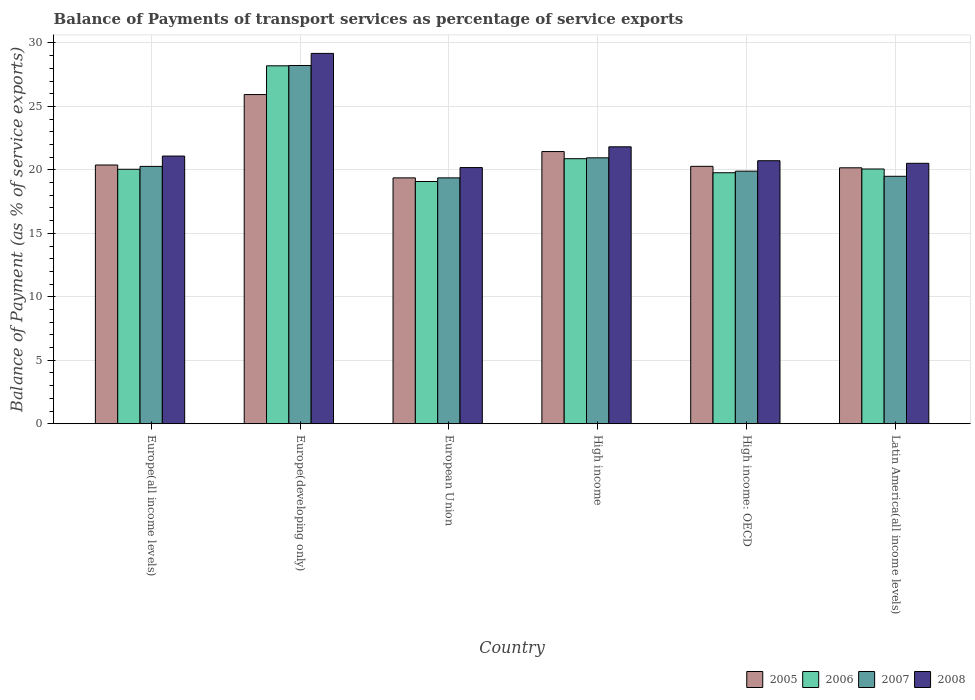How many bars are there on the 6th tick from the left?
Offer a very short reply. 4. What is the label of the 4th group of bars from the left?
Your response must be concise. High income. What is the balance of payments of transport services in 2006 in European Union?
Offer a very short reply. 19.09. Across all countries, what is the maximum balance of payments of transport services in 2006?
Offer a terse response. 28.2. Across all countries, what is the minimum balance of payments of transport services in 2005?
Your answer should be compact. 19.37. In which country was the balance of payments of transport services in 2005 maximum?
Offer a terse response. Europe(developing only). What is the total balance of payments of transport services in 2006 in the graph?
Offer a terse response. 128.07. What is the difference between the balance of payments of transport services in 2005 in Europe(all income levels) and that in Latin America(all income levels)?
Provide a succinct answer. 0.22. What is the difference between the balance of payments of transport services in 2005 in Latin America(all income levels) and the balance of payments of transport services in 2007 in Europe(all income levels)?
Provide a succinct answer. -0.11. What is the average balance of payments of transport services in 2008 per country?
Provide a succinct answer. 22.25. What is the difference between the balance of payments of transport services of/in 2007 and balance of payments of transport services of/in 2005 in High income?
Offer a terse response. -0.49. What is the ratio of the balance of payments of transport services in 2005 in Europe(all income levels) to that in High income?
Ensure brevity in your answer.  0.95. What is the difference between the highest and the second highest balance of payments of transport services in 2005?
Offer a very short reply. 5.55. What is the difference between the highest and the lowest balance of payments of transport services in 2006?
Your answer should be compact. 9.11. In how many countries, is the balance of payments of transport services in 2006 greater than the average balance of payments of transport services in 2006 taken over all countries?
Offer a very short reply. 1. Is the sum of the balance of payments of transport services in 2005 in Europe(developing only) and High income: OECD greater than the maximum balance of payments of transport services in 2007 across all countries?
Provide a succinct answer. Yes. Is it the case that in every country, the sum of the balance of payments of transport services in 2005 and balance of payments of transport services in 2007 is greater than the sum of balance of payments of transport services in 2008 and balance of payments of transport services in 2006?
Ensure brevity in your answer.  No. How many bars are there?
Your answer should be compact. 24. Are all the bars in the graph horizontal?
Offer a terse response. No. How many countries are there in the graph?
Your answer should be compact. 6. What is the difference between two consecutive major ticks on the Y-axis?
Keep it short and to the point. 5. Does the graph contain any zero values?
Offer a very short reply. No. Does the graph contain grids?
Your response must be concise. Yes. Where does the legend appear in the graph?
Offer a very short reply. Bottom right. What is the title of the graph?
Your answer should be compact. Balance of Payments of transport services as percentage of service exports. Does "1968" appear as one of the legend labels in the graph?
Your answer should be very brief. No. What is the label or title of the Y-axis?
Provide a succinct answer. Balance of Payment (as % of service exports). What is the Balance of Payment (as % of service exports) of 2005 in Europe(all income levels)?
Ensure brevity in your answer.  20.39. What is the Balance of Payment (as % of service exports) of 2006 in Europe(all income levels)?
Offer a very short reply. 20.05. What is the Balance of Payment (as % of service exports) in 2007 in Europe(all income levels)?
Your answer should be very brief. 20.28. What is the Balance of Payment (as % of service exports) in 2008 in Europe(all income levels)?
Provide a short and direct response. 21.09. What is the Balance of Payment (as % of service exports) of 2005 in Europe(developing only)?
Keep it short and to the point. 25.94. What is the Balance of Payment (as % of service exports) of 2006 in Europe(developing only)?
Ensure brevity in your answer.  28.2. What is the Balance of Payment (as % of service exports) of 2007 in Europe(developing only)?
Offer a very short reply. 28.23. What is the Balance of Payment (as % of service exports) of 2008 in Europe(developing only)?
Give a very brief answer. 29.18. What is the Balance of Payment (as % of service exports) in 2005 in European Union?
Make the answer very short. 19.37. What is the Balance of Payment (as % of service exports) of 2006 in European Union?
Ensure brevity in your answer.  19.09. What is the Balance of Payment (as % of service exports) in 2007 in European Union?
Make the answer very short. 19.37. What is the Balance of Payment (as % of service exports) in 2008 in European Union?
Give a very brief answer. 20.18. What is the Balance of Payment (as % of service exports) in 2005 in High income?
Give a very brief answer. 21.44. What is the Balance of Payment (as % of service exports) in 2006 in High income?
Offer a terse response. 20.88. What is the Balance of Payment (as % of service exports) of 2007 in High income?
Provide a succinct answer. 20.95. What is the Balance of Payment (as % of service exports) of 2008 in High income?
Your answer should be very brief. 21.82. What is the Balance of Payment (as % of service exports) of 2005 in High income: OECD?
Offer a terse response. 20.28. What is the Balance of Payment (as % of service exports) in 2006 in High income: OECD?
Offer a very short reply. 19.78. What is the Balance of Payment (as % of service exports) of 2007 in High income: OECD?
Ensure brevity in your answer.  19.9. What is the Balance of Payment (as % of service exports) in 2008 in High income: OECD?
Offer a terse response. 20.72. What is the Balance of Payment (as % of service exports) in 2005 in Latin America(all income levels)?
Make the answer very short. 20.17. What is the Balance of Payment (as % of service exports) in 2006 in Latin America(all income levels)?
Your answer should be compact. 20.07. What is the Balance of Payment (as % of service exports) in 2007 in Latin America(all income levels)?
Make the answer very short. 19.5. What is the Balance of Payment (as % of service exports) in 2008 in Latin America(all income levels)?
Ensure brevity in your answer.  20.52. Across all countries, what is the maximum Balance of Payment (as % of service exports) in 2005?
Your answer should be compact. 25.94. Across all countries, what is the maximum Balance of Payment (as % of service exports) of 2006?
Provide a short and direct response. 28.2. Across all countries, what is the maximum Balance of Payment (as % of service exports) of 2007?
Offer a very short reply. 28.23. Across all countries, what is the maximum Balance of Payment (as % of service exports) of 2008?
Provide a short and direct response. 29.18. Across all countries, what is the minimum Balance of Payment (as % of service exports) in 2005?
Keep it short and to the point. 19.37. Across all countries, what is the minimum Balance of Payment (as % of service exports) of 2006?
Offer a very short reply. 19.09. Across all countries, what is the minimum Balance of Payment (as % of service exports) of 2007?
Ensure brevity in your answer.  19.37. Across all countries, what is the minimum Balance of Payment (as % of service exports) in 2008?
Offer a very short reply. 20.18. What is the total Balance of Payment (as % of service exports) in 2005 in the graph?
Provide a short and direct response. 127.58. What is the total Balance of Payment (as % of service exports) of 2006 in the graph?
Your response must be concise. 128.07. What is the total Balance of Payment (as % of service exports) of 2007 in the graph?
Make the answer very short. 128.22. What is the total Balance of Payment (as % of service exports) of 2008 in the graph?
Keep it short and to the point. 133.51. What is the difference between the Balance of Payment (as % of service exports) in 2005 in Europe(all income levels) and that in Europe(developing only)?
Offer a terse response. -5.55. What is the difference between the Balance of Payment (as % of service exports) of 2006 in Europe(all income levels) and that in Europe(developing only)?
Offer a terse response. -8.15. What is the difference between the Balance of Payment (as % of service exports) of 2007 in Europe(all income levels) and that in Europe(developing only)?
Provide a succinct answer. -7.95. What is the difference between the Balance of Payment (as % of service exports) of 2008 in Europe(all income levels) and that in Europe(developing only)?
Your response must be concise. -8.09. What is the difference between the Balance of Payment (as % of service exports) of 2005 in Europe(all income levels) and that in European Union?
Provide a short and direct response. 1.01. What is the difference between the Balance of Payment (as % of service exports) in 2006 in Europe(all income levels) and that in European Union?
Offer a terse response. 0.96. What is the difference between the Balance of Payment (as % of service exports) in 2007 in Europe(all income levels) and that in European Union?
Your answer should be compact. 0.9. What is the difference between the Balance of Payment (as % of service exports) in 2008 in Europe(all income levels) and that in European Union?
Make the answer very short. 0.91. What is the difference between the Balance of Payment (as % of service exports) in 2005 in Europe(all income levels) and that in High income?
Your answer should be compact. -1.06. What is the difference between the Balance of Payment (as % of service exports) in 2006 in Europe(all income levels) and that in High income?
Provide a succinct answer. -0.83. What is the difference between the Balance of Payment (as % of service exports) of 2007 in Europe(all income levels) and that in High income?
Provide a succinct answer. -0.67. What is the difference between the Balance of Payment (as % of service exports) of 2008 in Europe(all income levels) and that in High income?
Provide a short and direct response. -0.73. What is the difference between the Balance of Payment (as % of service exports) in 2005 in Europe(all income levels) and that in High income: OECD?
Offer a terse response. 0.11. What is the difference between the Balance of Payment (as % of service exports) in 2006 in Europe(all income levels) and that in High income: OECD?
Keep it short and to the point. 0.27. What is the difference between the Balance of Payment (as % of service exports) of 2007 in Europe(all income levels) and that in High income: OECD?
Provide a short and direct response. 0.38. What is the difference between the Balance of Payment (as % of service exports) of 2008 in Europe(all income levels) and that in High income: OECD?
Offer a very short reply. 0.37. What is the difference between the Balance of Payment (as % of service exports) of 2005 in Europe(all income levels) and that in Latin America(all income levels)?
Keep it short and to the point. 0.22. What is the difference between the Balance of Payment (as % of service exports) in 2006 in Europe(all income levels) and that in Latin America(all income levels)?
Ensure brevity in your answer.  -0.02. What is the difference between the Balance of Payment (as % of service exports) in 2007 in Europe(all income levels) and that in Latin America(all income levels)?
Your response must be concise. 0.78. What is the difference between the Balance of Payment (as % of service exports) of 2008 in Europe(all income levels) and that in Latin America(all income levels)?
Your answer should be compact. 0.57. What is the difference between the Balance of Payment (as % of service exports) in 2005 in Europe(developing only) and that in European Union?
Make the answer very short. 6.56. What is the difference between the Balance of Payment (as % of service exports) of 2006 in Europe(developing only) and that in European Union?
Your answer should be compact. 9.11. What is the difference between the Balance of Payment (as % of service exports) in 2007 in Europe(developing only) and that in European Union?
Offer a very short reply. 8.85. What is the difference between the Balance of Payment (as % of service exports) of 2008 in Europe(developing only) and that in European Union?
Make the answer very short. 9. What is the difference between the Balance of Payment (as % of service exports) in 2005 in Europe(developing only) and that in High income?
Offer a very short reply. 4.49. What is the difference between the Balance of Payment (as % of service exports) in 2006 in Europe(developing only) and that in High income?
Keep it short and to the point. 7.32. What is the difference between the Balance of Payment (as % of service exports) of 2007 in Europe(developing only) and that in High income?
Provide a succinct answer. 7.28. What is the difference between the Balance of Payment (as % of service exports) of 2008 in Europe(developing only) and that in High income?
Offer a very short reply. 7.36. What is the difference between the Balance of Payment (as % of service exports) of 2005 in Europe(developing only) and that in High income: OECD?
Keep it short and to the point. 5.66. What is the difference between the Balance of Payment (as % of service exports) in 2006 in Europe(developing only) and that in High income: OECD?
Your answer should be very brief. 8.43. What is the difference between the Balance of Payment (as % of service exports) of 2007 in Europe(developing only) and that in High income: OECD?
Your answer should be very brief. 8.33. What is the difference between the Balance of Payment (as % of service exports) of 2008 in Europe(developing only) and that in High income: OECD?
Ensure brevity in your answer.  8.46. What is the difference between the Balance of Payment (as % of service exports) of 2005 in Europe(developing only) and that in Latin America(all income levels)?
Your response must be concise. 5.77. What is the difference between the Balance of Payment (as % of service exports) in 2006 in Europe(developing only) and that in Latin America(all income levels)?
Offer a terse response. 8.13. What is the difference between the Balance of Payment (as % of service exports) in 2007 in Europe(developing only) and that in Latin America(all income levels)?
Make the answer very short. 8.73. What is the difference between the Balance of Payment (as % of service exports) in 2008 in Europe(developing only) and that in Latin America(all income levels)?
Offer a terse response. 8.66. What is the difference between the Balance of Payment (as % of service exports) of 2005 in European Union and that in High income?
Provide a succinct answer. -2.07. What is the difference between the Balance of Payment (as % of service exports) in 2006 in European Union and that in High income?
Make the answer very short. -1.8. What is the difference between the Balance of Payment (as % of service exports) of 2007 in European Union and that in High income?
Provide a succinct answer. -1.58. What is the difference between the Balance of Payment (as % of service exports) in 2008 in European Union and that in High income?
Make the answer very short. -1.64. What is the difference between the Balance of Payment (as % of service exports) in 2005 in European Union and that in High income: OECD?
Ensure brevity in your answer.  -0.91. What is the difference between the Balance of Payment (as % of service exports) in 2006 in European Union and that in High income: OECD?
Ensure brevity in your answer.  -0.69. What is the difference between the Balance of Payment (as % of service exports) of 2007 in European Union and that in High income: OECD?
Offer a very short reply. -0.53. What is the difference between the Balance of Payment (as % of service exports) of 2008 in European Union and that in High income: OECD?
Offer a terse response. -0.54. What is the difference between the Balance of Payment (as % of service exports) of 2005 in European Union and that in Latin America(all income levels)?
Offer a very short reply. -0.79. What is the difference between the Balance of Payment (as % of service exports) in 2006 in European Union and that in Latin America(all income levels)?
Your answer should be very brief. -0.98. What is the difference between the Balance of Payment (as % of service exports) of 2007 in European Union and that in Latin America(all income levels)?
Keep it short and to the point. -0.12. What is the difference between the Balance of Payment (as % of service exports) of 2008 in European Union and that in Latin America(all income levels)?
Ensure brevity in your answer.  -0.34. What is the difference between the Balance of Payment (as % of service exports) of 2005 in High income and that in High income: OECD?
Your answer should be very brief. 1.16. What is the difference between the Balance of Payment (as % of service exports) of 2006 in High income and that in High income: OECD?
Provide a succinct answer. 1.11. What is the difference between the Balance of Payment (as % of service exports) of 2007 in High income and that in High income: OECD?
Give a very brief answer. 1.05. What is the difference between the Balance of Payment (as % of service exports) of 2008 in High income and that in High income: OECD?
Provide a succinct answer. 1.1. What is the difference between the Balance of Payment (as % of service exports) in 2005 in High income and that in Latin America(all income levels)?
Give a very brief answer. 1.28. What is the difference between the Balance of Payment (as % of service exports) of 2006 in High income and that in Latin America(all income levels)?
Provide a succinct answer. 0.81. What is the difference between the Balance of Payment (as % of service exports) of 2007 in High income and that in Latin America(all income levels)?
Make the answer very short. 1.45. What is the difference between the Balance of Payment (as % of service exports) in 2008 in High income and that in Latin America(all income levels)?
Provide a succinct answer. 1.3. What is the difference between the Balance of Payment (as % of service exports) in 2005 in High income: OECD and that in Latin America(all income levels)?
Offer a very short reply. 0.11. What is the difference between the Balance of Payment (as % of service exports) of 2006 in High income: OECD and that in Latin America(all income levels)?
Your answer should be compact. -0.3. What is the difference between the Balance of Payment (as % of service exports) of 2007 in High income: OECD and that in Latin America(all income levels)?
Make the answer very short. 0.4. What is the difference between the Balance of Payment (as % of service exports) of 2008 in High income: OECD and that in Latin America(all income levels)?
Offer a terse response. 0.2. What is the difference between the Balance of Payment (as % of service exports) of 2005 in Europe(all income levels) and the Balance of Payment (as % of service exports) of 2006 in Europe(developing only)?
Offer a terse response. -7.82. What is the difference between the Balance of Payment (as % of service exports) in 2005 in Europe(all income levels) and the Balance of Payment (as % of service exports) in 2007 in Europe(developing only)?
Ensure brevity in your answer.  -7.84. What is the difference between the Balance of Payment (as % of service exports) of 2005 in Europe(all income levels) and the Balance of Payment (as % of service exports) of 2008 in Europe(developing only)?
Provide a short and direct response. -8.79. What is the difference between the Balance of Payment (as % of service exports) in 2006 in Europe(all income levels) and the Balance of Payment (as % of service exports) in 2007 in Europe(developing only)?
Your answer should be compact. -8.18. What is the difference between the Balance of Payment (as % of service exports) in 2006 in Europe(all income levels) and the Balance of Payment (as % of service exports) in 2008 in Europe(developing only)?
Your answer should be very brief. -9.13. What is the difference between the Balance of Payment (as % of service exports) of 2007 in Europe(all income levels) and the Balance of Payment (as % of service exports) of 2008 in Europe(developing only)?
Provide a short and direct response. -8.9. What is the difference between the Balance of Payment (as % of service exports) in 2005 in Europe(all income levels) and the Balance of Payment (as % of service exports) in 2006 in European Union?
Your answer should be very brief. 1.3. What is the difference between the Balance of Payment (as % of service exports) in 2005 in Europe(all income levels) and the Balance of Payment (as % of service exports) in 2007 in European Union?
Your response must be concise. 1.01. What is the difference between the Balance of Payment (as % of service exports) in 2005 in Europe(all income levels) and the Balance of Payment (as % of service exports) in 2008 in European Union?
Provide a succinct answer. 0.2. What is the difference between the Balance of Payment (as % of service exports) of 2006 in Europe(all income levels) and the Balance of Payment (as % of service exports) of 2007 in European Union?
Make the answer very short. 0.68. What is the difference between the Balance of Payment (as % of service exports) of 2006 in Europe(all income levels) and the Balance of Payment (as % of service exports) of 2008 in European Union?
Your answer should be very brief. -0.13. What is the difference between the Balance of Payment (as % of service exports) of 2007 in Europe(all income levels) and the Balance of Payment (as % of service exports) of 2008 in European Union?
Make the answer very short. 0.09. What is the difference between the Balance of Payment (as % of service exports) of 2005 in Europe(all income levels) and the Balance of Payment (as % of service exports) of 2006 in High income?
Provide a short and direct response. -0.5. What is the difference between the Balance of Payment (as % of service exports) in 2005 in Europe(all income levels) and the Balance of Payment (as % of service exports) in 2007 in High income?
Your response must be concise. -0.56. What is the difference between the Balance of Payment (as % of service exports) of 2005 in Europe(all income levels) and the Balance of Payment (as % of service exports) of 2008 in High income?
Offer a very short reply. -1.43. What is the difference between the Balance of Payment (as % of service exports) of 2006 in Europe(all income levels) and the Balance of Payment (as % of service exports) of 2007 in High income?
Keep it short and to the point. -0.9. What is the difference between the Balance of Payment (as % of service exports) in 2006 in Europe(all income levels) and the Balance of Payment (as % of service exports) in 2008 in High income?
Offer a very short reply. -1.77. What is the difference between the Balance of Payment (as % of service exports) in 2007 in Europe(all income levels) and the Balance of Payment (as % of service exports) in 2008 in High income?
Ensure brevity in your answer.  -1.54. What is the difference between the Balance of Payment (as % of service exports) of 2005 in Europe(all income levels) and the Balance of Payment (as % of service exports) of 2006 in High income: OECD?
Ensure brevity in your answer.  0.61. What is the difference between the Balance of Payment (as % of service exports) in 2005 in Europe(all income levels) and the Balance of Payment (as % of service exports) in 2007 in High income: OECD?
Offer a very short reply. 0.49. What is the difference between the Balance of Payment (as % of service exports) in 2005 in Europe(all income levels) and the Balance of Payment (as % of service exports) in 2008 in High income: OECD?
Make the answer very short. -0.34. What is the difference between the Balance of Payment (as % of service exports) of 2006 in Europe(all income levels) and the Balance of Payment (as % of service exports) of 2007 in High income: OECD?
Offer a terse response. 0.15. What is the difference between the Balance of Payment (as % of service exports) of 2006 in Europe(all income levels) and the Balance of Payment (as % of service exports) of 2008 in High income: OECD?
Give a very brief answer. -0.67. What is the difference between the Balance of Payment (as % of service exports) of 2007 in Europe(all income levels) and the Balance of Payment (as % of service exports) of 2008 in High income: OECD?
Make the answer very short. -0.45. What is the difference between the Balance of Payment (as % of service exports) of 2005 in Europe(all income levels) and the Balance of Payment (as % of service exports) of 2006 in Latin America(all income levels)?
Provide a succinct answer. 0.31. What is the difference between the Balance of Payment (as % of service exports) in 2005 in Europe(all income levels) and the Balance of Payment (as % of service exports) in 2007 in Latin America(all income levels)?
Your answer should be very brief. 0.89. What is the difference between the Balance of Payment (as % of service exports) in 2005 in Europe(all income levels) and the Balance of Payment (as % of service exports) in 2008 in Latin America(all income levels)?
Give a very brief answer. -0.13. What is the difference between the Balance of Payment (as % of service exports) of 2006 in Europe(all income levels) and the Balance of Payment (as % of service exports) of 2007 in Latin America(all income levels)?
Offer a terse response. 0.55. What is the difference between the Balance of Payment (as % of service exports) of 2006 in Europe(all income levels) and the Balance of Payment (as % of service exports) of 2008 in Latin America(all income levels)?
Offer a very short reply. -0.47. What is the difference between the Balance of Payment (as % of service exports) in 2007 in Europe(all income levels) and the Balance of Payment (as % of service exports) in 2008 in Latin America(all income levels)?
Provide a short and direct response. -0.24. What is the difference between the Balance of Payment (as % of service exports) of 2005 in Europe(developing only) and the Balance of Payment (as % of service exports) of 2006 in European Union?
Your response must be concise. 6.85. What is the difference between the Balance of Payment (as % of service exports) in 2005 in Europe(developing only) and the Balance of Payment (as % of service exports) in 2007 in European Union?
Your response must be concise. 6.57. What is the difference between the Balance of Payment (as % of service exports) in 2005 in Europe(developing only) and the Balance of Payment (as % of service exports) in 2008 in European Union?
Give a very brief answer. 5.75. What is the difference between the Balance of Payment (as % of service exports) in 2006 in Europe(developing only) and the Balance of Payment (as % of service exports) in 2007 in European Union?
Your answer should be compact. 8.83. What is the difference between the Balance of Payment (as % of service exports) of 2006 in Europe(developing only) and the Balance of Payment (as % of service exports) of 2008 in European Union?
Offer a very short reply. 8.02. What is the difference between the Balance of Payment (as % of service exports) of 2007 in Europe(developing only) and the Balance of Payment (as % of service exports) of 2008 in European Union?
Ensure brevity in your answer.  8.04. What is the difference between the Balance of Payment (as % of service exports) of 2005 in Europe(developing only) and the Balance of Payment (as % of service exports) of 2006 in High income?
Offer a terse response. 5.05. What is the difference between the Balance of Payment (as % of service exports) of 2005 in Europe(developing only) and the Balance of Payment (as % of service exports) of 2007 in High income?
Ensure brevity in your answer.  4.99. What is the difference between the Balance of Payment (as % of service exports) of 2005 in Europe(developing only) and the Balance of Payment (as % of service exports) of 2008 in High income?
Offer a terse response. 4.12. What is the difference between the Balance of Payment (as % of service exports) of 2006 in Europe(developing only) and the Balance of Payment (as % of service exports) of 2007 in High income?
Offer a terse response. 7.25. What is the difference between the Balance of Payment (as % of service exports) of 2006 in Europe(developing only) and the Balance of Payment (as % of service exports) of 2008 in High income?
Provide a succinct answer. 6.38. What is the difference between the Balance of Payment (as % of service exports) of 2007 in Europe(developing only) and the Balance of Payment (as % of service exports) of 2008 in High income?
Provide a succinct answer. 6.41. What is the difference between the Balance of Payment (as % of service exports) in 2005 in Europe(developing only) and the Balance of Payment (as % of service exports) in 2006 in High income: OECD?
Offer a terse response. 6.16. What is the difference between the Balance of Payment (as % of service exports) of 2005 in Europe(developing only) and the Balance of Payment (as % of service exports) of 2007 in High income: OECD?
Offer a terse response. 6.04. What is the difference between the Balance of Payment (as % of service exports) in 2005 in Europe(developing only) and the Balance of Payment (as % of service exports) in 2008 in High income: OECD?
Your response must be concise. 5.21. What is the difference between the Balance of Payment (as % of service exports) in 2006 in Europe(developing only) and the Balance of Payment (as % of service exports) in 2007 in High income: OECD?
Ensure brevity in your answer.  8.3. What is the difference between the Balance of Payment (as % of service exports) in 2006 in Europe(developing only) and the Balance of Payment (as % of service exports) in 2008 in High income: OECD?
Ensure brevity in your answer.  7.48. What is the difference between the Balance of Payment (as % of service exports) of 2007 in Europe(developing only) and the Balance of Payment (as % of service exports) of 2008 in High income: OECD?
Provide a short and direct response. 7.5. What is the difference between the Balance of Payment (as % of service exports) in 2005 in Europe(developing only) and the Balance of Payment (as % of service exports) in 2006 in Latin America(all income levels)?
Give a very brief answer. 5.87. What is the difference between the Balance of Payment (as % of service exports) in 2005 in Europe(developing only) and the Balance of Payment (as % of service exports) in 2007 in Latin America(all income levels)?
Offer a terse response. 6.44. What is the difference between the Balance of Payment (as % of service exports) in 2005 in Europe(developing only) and the Balance of Payment (as % of service exports) in 2008 in Latin America(all income levels)?
Ensure brevity in your answer.  5.42. What is the difference between the Balance of Payment (as % of service exports) in 2006 in Europe(developing only) and the Balance of Payment (as % of service exports) in 2007 in Latin America(all income levels)?
Your response must be concise. 8.7. What is the difference between the Balance of Payment (as % of service exports) in 2006 in Europe(developing only) and the Balance of Payment (as % of service exports) in 2008 in Latin America(all income levels)?
Give a very brief answer. 7.68. What is the difference between the Balance of Payment (as % of service exports) of 2007 in Europe(developing only) and the Balance of Payment (as % of service exports) of 2008 in Latin America(all income levels)?
Your response must be concise. 7.71. What is the difference between the Balance of Payment (as % of service exports) of 2005 in European Union and the Balance of Payment (as % of service exports) of 2006 in High income?
Ensure brevity in your answer.  -1.51. What is the difference between the Balance of Payment (as % of service exports) of 2005 in European Union and the Balance of Payment (as % of service exports) of 2007 in High income?
Give a very brief answer. -1.58. What is the difference between the Balance of Payment (as % of service exports) in 2005 in European Union and the Balance of Payment (as % of service exports) in 2008 in High income?
Offer a terse response. -2.45. What is the difference between the Balance of Payment (as % of service exports) of 2006 in European Union and the Balance of Payment (as % of service exports) of 2007 in High income?
Keep it short and to the point. -1.86. What is the difference between the Balance of Payment (as % of service exports) in 2006 in European Union and the Balance of Payment (as % of service exports) in 2008 in High income?
Provide a short and direct response. -2.73. What is the difference between the Balance of Payment (as % of service exports) of 2007 in European Union and the Balance of Payment (as % of service exports) of 2008 in High income?
Offer a terse response. -2.45. What is the difference between the Balance of Payment (as % of service exports) in 2005 in European Union and the Balance of Payment (as % of service exports) in 2006 in High income: OECD?
Your response must be concise. -0.4. What is the difference between the Balance of Payment (as % of service exports) of 2005 in European Union and the Balance of Payment (as % of service exports) of 2007 in High income: OECD?
Ensure brevity in your answer.  -0.53. What is the difference between the Balance of Payment (as % of service exports) in 2005 in European Union and the Balance of Payment (as % of service exports) in 2008 in High income: OECD?
Keep it short and to the point. -1.35. What is the difference between the Balance of Payment (as % of service exports) of 2006 in European Union and the Balance of Payment (as % of service exports) of 2007 in High income: OECD?
Provide a short and direct response. -0.81. What is the difference between the Balance of Payment (as % of service exports) of 2006 in European Union and the Balance of Payment (as % of service exports) of 2008 in High income: OECD?
Offer a very short reply. -1.64. What is the difference between the Balance of Payment (as % of service exports) of 2007 in European Union and the Balance of Payment (as % of service exports) of 2008 in High income: OECD?
Ensure brevity in your answer.  -1.35. What is the difference between the Balance of Payment (as % of service exports) of 2005 in European Union and the Balance of Payment (as % of service exports) of 2006 in Latin America(all income levels)?
Your response must be concise. -0.7. What is the difference between the Balance of Payment (as % of service exports) of 2005 in European Union and the Balance of Payment (as % of service exports) of 2007 in Latin America(all income levels)?
Your answer should be very brief. -0.12. What is the difference between the Balance of Payment (as % of service exports) in 2005 in European Union and the Balance of Payment (as % of service exports) in 2008 in Latin America(all income levels)?
Provide a succinct answer. -1.15. What is the difference between the Balance of Payment (as % of service exports) of 2006 in European Union and the Balance of Payment (as % of service exports) of 2007 in Latin America(all income levels)?
Offer a terse response. -0.41. What is the difference between the Balance of Payment (as % of service exports) in 2006 in European Union and the Balance of Payment (as % of service exports) in 2008 in Latin America(all income levels)?
Provide a short and direct response. -1.43. What is the difference between the Balance of Payment (as % of service exports) of 2007 in European Union and the Balance of Payment (as % of service exports) of 2008 in Latin America(all income levels)?
Offer a terse response. -1.15. What is the difference between the Balance of Payment (as % of service exports) in 2005 in High income and the Balance of Payment (as % of service exports) in 2006 in High income: OECD?
Give a very brief answer. 1.67. What is the difference between the Balance of Payment (as % of service exports) of 2005 in High income and the Balance of Payment (as % of service exports) of 2007 in High income: OECD?
Offer a terse response. 1.54. What is the difference between the Balance of Payment (as % of service exports) of 2005 in High income and the Balance of Payment (as % of service exports) of 2008 in High income: OECD?
Make the answer very short. 0.72. What is the difference between the Balance of Payment (as % of service exports) of 2006 in High income and the Balance of Payment (as % of service exports) of 2007 in High income: OECD?
Your response must be concise. 0.98. What is the difference between the Balance of Payment (as % of service exports) of 2006 in High income and the Balance of Payment (as % of service exports) of 2008 in High income: OECD?
Your answer should be compact. 0.16. What is the difference between the Balance of Payment (as % of service exports) in 2007 in High income and the Balance of Payment (as % of service exports) in 2008 in High income: OECD?
Make the answer very short. 0.23. What is the difference between the Balance of Payment (as % of service exports) in 2005 in High income and the Balance of Payment (as % of service exports) in 2006 in Latin America(all income levels)?
Keep it short and to the point. 1.37. What is the difference between the Balance of Payment (as % of service exports) in 2005 in High income and the Balance of Payment (as % of service exports) in 2007 in Latin America(all income levels)?
Provide a succinct answer. 1.95. What is the difference between the Balance of Payment (as % of service exports) in 2005 in High income and the Balance of Payment (as % of service exports) in 2008 in Latin America(all income levels)?
Provide a short and direct response. 0.93. What is the difference between the Balance of Payment (as % of service exports) of 2006 in High income and the Balance of Payment (as % of service exports) of 2007 in Latin America(all income levels)?
Give a very brief answer. 1.39. What is the difference between the Balance of Payment (as % of service exports) in 2006 in High income and the Balance of Payment (as % of service exports) in 2008 in Latin America(all income levels)?
Your answer should be compact. 0.36. What is the difference between the Balance of Payment (as % of service exports) in 2007 in High income and the Balance of Payment (as % of service exports) in 2008 in Latin America(all income levels)?
Your response must be concise. 0.43. What is the difference between the Balance of Payment (as % of service exports) in 2005 in High income: OECD and the Balance of Payment (as % of service exports) in 2006 in Latin America(all income levels)?
Make the answer very short. 0.21. What is the difference between the Balance of Payment (as % of service exports) in 2005 in High income: OECD and the Balance of Payment (as % of service exports) in 2007 in Latin America(all income levels)?
Ensure brevity in your answer.  0.78. What is the difference between the Balance of Payment (as % of service exports) of 2005 in High income: OECD and the Balance of Payment (as % of service exports) of 2008 in Latin America(all income levels)?
Make the answer very short. -0.24. What is the difference between the Balance of Payment (as % of service exports) in 2006 in High income: OECD and the Balance of Payment (as % of service exports) in 2007 in Latin America(all income levels)?
Make the answer very short. 0.28. What is the difference between the Balance of Payment (as % of service exports) of 2006 in High income: OECD and the Balance of Payment (as % of service exports) of 2008 in Latin America(all income levels)?
Your answer should be compact. -0.74. What is the difference between the Balance of Payment (as % of service exports) of 2007 in High income: OECD and the Balance of Payment (as % of service exports) of 2008 in Latin America(all income levels)?
Your response must be concise. -0.62. What is the average Balance of Payment (as % of service exports) in 2005 per country?
Your response must be concise. 21.26. What is the average Balance of Payment (as % of service exports) of 2006 per country?
Provide a short and direct response. 21.34. What is the average Balance of Payment (as % of service exports) of 2007 per country?
Give a very brief answer. 21.37. What is the average Balance of Payment (as % of service exports) of 2008 per country?
Your answer should be compact. 22.25. What is the difference between the Balance of Payment (as % of service exports) in 2005 and Balance of Payment (as % of service exports) in 2006 in Europe(all income levels)?
Make the answer very short. 0.34. What is the difference between the Balance of Payment (as % of service exports) in 2005 and Balance of Payment (as % of service exports) in 2007 in Europe(all income levels)?
Ensure brevity in your answer.  0.11. What is the difference between the Balance of Payment (as % of service exports) of 2005 and Balance of Payment (as % of service exports) of 2008 in Europe(all income levels)?
Your answer should be very brief. -0.71. What is the difference between the Balance of Payment (as % of service exports) in 2006 and Balance of Payment (as % of service exports) in 2007 in Europe(all income levels)?
Provide a succinct answer. -0.23. What is the difference between the Balance of Payment (as % of service exports) in 2006 and Balance of Payment (as % of service exports) in 2008 in Europe(all income levels)?
Give a very brief answer. -1.04. What is the difference between the Balance of Payment (as % of service exports) in 2007 and Balance of Payment (as % of service exports) in 2008 in Europe(all income levels)?
Your answer should be very brief. -0.82. What is the difference between the Balance of Payment (as % of service exports) of 2005 and Balance of Payment (as % of service exports) of 2006 in Europe(developing only)?
Your answer should be very brief. -2.26. What is the difference between the Balance of Payment (as % of service exports) in 2005 and Balance of Payment (as % of service exports) in 2007 in Europe(developing only)?
Give a very brief answer. -2.29. What is the difference between the Balance of Payment (as % of service exports) of 2005 and Balance of Payment (as % of service exports) of 2008 in Europe(developing only)?
Keep it short and to the point. -3.24. What is the difference between the Balance of Payment (as % of service exports) in 2006 and Balance of Payment (as % of service exports) in 2007 in Europe(developing only)?
Keep it short and to the point. -0.02. What is the difference between the Balance of Payment (as % of service exports) of 2006 and Balance of Payment (as % of service exports) of 2008 in Europe(developing only)?
Make the answer very short. -0.98. What is the difference between the Balance of Payment (as % of service exports) in 2007 and Balance of Payment (as % of service exports) in 2008 in Europe(developing only)?
Keep it short and to the point. -0.95. What is the difference between the Balance of Payment (as % of service exports) in 2005 and Balance of Payment (as % of service exports) in 2006 in European Union?
Your answer should be very brief. 0.28. What is the difference between the Balance of Payment (as % of service exports) in 2005 and Balance of Payment (as % of service exports) in 2008 in European Union?
Offer a very short reply. -0.81. What is the difference between the Balance of Payment (as % of service exports) of 2006 and Balance of Payment (as % of service exports) of 2007 in European Union?
Your response must be concise. -0.28. What is the difference between the Balance of Payment (as % of service exports) of 2006 and Balance of Payment (as % of service exports) of 2008 in European Union?
Offer a terse response. -1.1. What is the difference between the Balance of Payment (as % of service exports) of 2007 and Balance of Payment (as % of service exports) of 2008 in European Union?
Provide a short and direct response. -0.81. What is the difference between the Balance of Payment (as % of service exports) of 2005 and Balance of Payment (as % of service exports) of 2006 in High income?
Give a very brief answer. 0.56. What is the difference between the Balance of Payment (as % of service exports) of 2005 and Balance of Payment (as % of service exports) of 2007 in High income?
Offer a very short reply. 0.49. What is the difference between the Balance of Payment (as % of service exports) of 2005 and Balance of Payment (as % of service exports) of 2008 in High income?
Provide a succinct answer. -0.37. What is the difference between the Balance of Payment (as % of service exports) in 2006 and Balance of Payment (as % of service exports) in 2007 in High income?
Your answer should be very brief. -0.07. What is the difference between the Balance of Payment (as % of service exports) in 2006 and Balance of Payment (as % of service exports) in 2008 in High income?
Your answer should be very brief. -0.94. What is the difference between the Balance of Payment (as % of service exports) of 2007 and Balance of Payment (as % of service exports) of 2008 in High income?
Give a very brief answer. -0.87. What is the difference between the Balance of Payment (as % of service exports) of 2005 and Balance of Payment (as % of service exports) of 2006 in High income: OECD?
Keep it short and to the point. 0.5. What is the difference between the Balance of Payment (as % of service exports) in 2005 and Balance of Payment (as % of service exports) in 2007 in High income: OECD?
Offer a very short reply. 0.38. What is the difference between the Balance of Payment (as % of service exports) of 2005 and Balance of Payment (as % of service exports) of 2008 in High income: OECD?
Your answer should be compact. -0.44. What is the difference between the Balance of Payment (as % of service exports) of 2006 and Balance of Payment (as % of service exports) of 2007 in High income: OECD?
Your answer should be very brief. -0.12. What is the difference between the Balance of Payment (as % of service exports) in 2006 and Balance of Payment (as % of service exports) in 2008 in High income: OECD?
Offer a very short reply. -0.95. What is the difference between the Balance of Payment (as % of service exports) of 2007 and Balance of Payment (as % of service exports) of 2008 in High income: OECD?
Offer a terse response. -0.82. What is the difference between the Balance of Payment (as % of service exports) of 2005 and Balance of Payment (as % of service exports) of 2006 in Latin America(all income levels)?
Provide a short and direct response. 0.09. What is the difference between the Balance of Payment (as % of service exports) of 2005 and Balance of Payment (as % of service exports) of 2007 in Latin America(all income levels)?
Keep it short and to the point. 0.67. What is the difference between the Balance of Payment (as % of service exports) in 2005 and Balance of Payment (as % of service exports) in 2008 in Latin America(all income levels)?
Provide a succinct answer. -0.35. What is the difference between the Balance of Payment (as % of service exports) in 2006 and Balance of Payment (as % of service exports) in 2007 in Latin America(all income levels)?
Your answer should be very brief. 0.57. What is the difference between the Balance of Payment (as % of service exports) in 2006 and Balance of Payment (as % of service exports) in 2008 in Latin America(all income levels)?
Offer a terse response. -0.45. What is the difference between the Balance of Payment (as % of service exports) in 2007 and Balance of Payment (as % of service exports) in 2008 in Latin America(all income levels)?
Your response must be concise. -1.02. What is the ratio of the Balance of Payment (as % of service exports) in 2005 in Europe(all income levels) to that in Europe(developing only)?
Provide a succinct answer. 0.79. What is the ratio of the Balance of Payment (as % of service exports) of 2006 in Europe(all income levels) to that in Europe(developing only)?
Provide a short and direct response. 0.71. What is the ratio of the Balance of Payment (as % of service exports) in 2007 in Europe(all income levels) to that in Europe(developing only)?
Provide a succinct answer. 0.72. What is the ratio of the Balance of Payment (as % of service exports) of 2008 in Europe(all income levels) to that in Europe(developing only)?
Keep it short and to the point. 0.72. What is the ratio of the Balance of Payment (as % of service exports) of 2005 in Europe(all income levels) to that in European Union?
Make the answer very short. 1.05. What is the ratio of the Balance of Payment (as % of service exports) of 2006 in Europe(all income levels) to that in European Union?
Your response must be concise. 1.05. What is the ratio of the Balance of Payment (as % of service exports) in 2007 in Europe(all income levels) to that in European Union?
Your response must be concise. 1.05. What is the ratio of the Balance of Payment (as % of service exports) in 2008 in Europe(all income levels) to that in European Union?
Your response must be concise. 1.04. What is the ratio of the Balance of Payment (as % of service exports) of 2005 in Europe(all income levels) to that in High income?
Give a very brief answer. 0.95. What is the ratio of the Balance of Payment (as % of service exports) in 2006 in Europe(all income levels) to that in High income?
Ensure brevity in your answer.  0.96. What is the ratio of the Balance of Payment (as % of service exports) in 2007 in Europe(all income levels) to that in High income?
Your response must be concise. 0.97. What is the ratio of the Balance of Payment (as % of service exports) of 2008 in Europe(all income levels) to that in High income?
Your answer should be compact. 0.97. What is the ratio of the Balance of Payment (as % of service exports) in 2005 in Europe(all income levels) to that in High income: OECD?
Give a very brief answer. 1.01. What is the ratio of the Balance of Payment (as % of service exports) in 2006 in Europe(all income levels) to that in High income: OECD?
Make the answer very short. 1.01. What is the ratio of the Balance of Payment (as % of service exports) in 2007 in Europe(all income levels) to that in High income: OECD?
Provide a succinct answer. 1.02. What is the ratio of the Balance of Payment (as % of service exports) in 2008 in Europe(all income levels) to that in High income: OECD?
Provide a short and direct response. 1.02. What is the ratio of the Balance of Payment (as % of service exports) of 2005 in Europe(all income levels) to that in Latin America(all income levels)?
Provide a succinct answer. 1.01. What is the ratio of the Balance of Payment (as % of service exports) in 2006 in Europe(all income levels) to that in Latin America(all income levels)?
Your answer should be very brief. 1. What is the ratio of the Balance of Payment (as % of service exports) in 2007 in Europe(all income levels) to that in Latin America(all income levels)?
Provide a short and direct response. 1.04. What is the ratio of the Balance of Payment (as % of service exports) in 2008 in Europe(all income levels) to that in Latin America(all income levels)?
Give a very brief answer. 1.03. What is the ratio of the Balance of Payment (as % of service exports) of 2005 in Europe(developing only) to that in European Union?
Provide a short and direct response. 1.34. What is the ratio of the Balance of Payment (as % of service exports) in 2006 in Europe(developing only) to that in European Union?
Offer a very short reply. 1.48. What is the ratio of the Balance of Payment (as % of service exports) in 2007 in Europe(developing only) to that in European Union?
Your answer should be very brief. 1.46. What is the ratio of the Balance of Payment (as % of service exports) of 2008 in Europe(developing only) to that in European Union?
Your response must be concise. 1.45. What is the ratio of the Balance of Payment (as % of service exports) of 2005 in Europe(developing only) to that in High income?
Offer a terse response. 1.21. What is the ratio of the Balance of Payment (as % of service exports) of 2006 in Europe(developing only) to that in High income?
Make the answer very short. 1.35. What is the ratio of the Balance of Payment (as % of service exports) in 2007 in Europe(developing only) to that in High income?
Ensure brevity in your answer.  1.35. What is the ratio of the Balance of Payment (as % of service exports) of 2008 in Europe(developing only) to that in High income?
Your answer should be very brief. 1.34. What is the ratio of the Balance of Payment (as % of service exports) of 2005 in Europe(developing only) to that in High income: OECD?
Ensure brevity in your answer.  1.28. What is the ratio of the Balance of Payment (as % of service exports) of 2006 in Europe(developing only) to that in High income: OECD?
Your answer should be very brief. 1.43. What is the ratio of the Balance of Payment (as % of service exports) of 2007 in Europe(developing only) to that in High income: OECD?
Offer a very short reply. 1.42. What is the ratio of the Balance of Payment (as % of service exports) in 2008 in Europe(developing only) to that in High income: OECD?
Make the answer very short. 1.41. What is the ratio of the Balance of Payment (as % of service exports) of 2005 in Europe(developing only) to that in Latin America(all income levels)?
Provide a succinct answer. 1.29. What is the ratio of the Balance of Payment (as % of service exports) in 2006 in Europe(developing only) to that in Latin America(all income levels)?
Provide a succinct answer. 1.41. What is the ratio of the Balance of Payment (as % of service exports) of 2007 in Europe(developing only) to that in Latin America(all income levels)?
Offer a terse response. 1.45. What is the ratio of the Balance of Payment (as % of service exports) in 2008 in Europe(developing only) to that in Latin America(all income levels)?
Provide a succinct answer. 1.42. What is the ratio of the Balance of Payment (as % of service exports) in 2005 in European Union to that in High income?
Your answer should be very brief. 0.9. What is the ratio of the Balance of Payment (as % of service exports) in 2006 in European Union to that in High income?
Keep it short and to the point. 0.91. What is the ratio of the Balance of Payment (as % of service exports) in 2007 in European Union to that in High income?
Your answer should be very brief. 0.92. What is the ratio of the Balance of Payment (as % of service exports) in 2008 in European Union to that in High income?
Offer a terse response. 0.93. What is the ratio of the Balance of Payment (as % of service exports) of 2005 in European Union to that in High income: OECD?
Provide a succinct answer. 0.96. What is the ratio of the Balance of Payment (as % of service exports) of 2006 in European Union to that in High income: OECD?
Keep it short and to the point. 0.97. What is the ratio of the Balance of Payment (as % of service exports) in 2007 in European Union to that in High income: OECD?
Your response must be concise. 0.97. What is the ratio of the Balance of Payment (as % of service exports) in 2008 in European Union to that in High income: OECD?
Your response must be concise. 0.97. What is the ratio of the Balance of Payment (as % of service exports) of 2005 in European Union to that in Latin America(all income levels)?
Provide a short and direct response. 0.96. What is the ratio of the Balance of Payment (as % of service exports) of 2006 in European Union to that in Latin America(all income levels)?
Give a very brief answer. 0.95. What is the ratio of the Balance of Payment (as % of service exports) of 2008 in European Union to that in Latin America(all income levels)?
Your answer should be very brief. 0.98. What is the ratio of the Balance of Payment (as % of service exports) of 2005 in High income to that in High income: OECD?
Give a very brief answer. 1.06. What is the ratio of the Balance of Payment (as % of service exports) of 2006 in High income to that in High income: OECD?
Provide a short and direct response. 1.06. What is the ratio of the Balance of Payment (as % of service exports) in 2007 in High income to that in High income: OECD?
Give a very brief answer. 1.05. What is the ratio of the Balance of Payment (as % of service exports) of 2008 in High income to that in High income: OECD?
Your answer should be very brief. 1.05. What is the ratio of the Balance of Payment (as % of service exports) in 2005 in High income to that in Latin America(all income levels)?
Offer a terse response. 1.06. What is the ratio of the Balance of Payment (as % of service exports) in 2006 in High income to that in Latin America(all income levels)?
Offer a very short reply. 1.04. What is the ratio of the Balance of Payment (as % of service exports) of 2007 in High income to that in Latin America(all income levels)?
Provide a short and direct response. 1.07. What is the ratio of the Balance of Payment (as % of service exports) in 2008 in High income to that in Latin America(all income levels)?
Offer a very short reply. 1.06. What is the ratio of the Balance of Payment (as % of service exports) in 2006 in High income: OECD to that in Latin America(all income levels)?
Ensure brevity in your answer.  0.99. What is the ratio of the Balance of Payment (as % of service exports) in 2007 in High income: OECD to that in Latin America(all income levels)?
Give a very brief answer. 1.02. What is the ratio of the Balance of Payment (as % of service exports) of 2008 in High income: OECD to that in Latin America(all income levels)?
Keep it short and to the point. 1.01. What is the difference between the highest and the second highest Balance of Payment (as % of service exports) in 2005?
Make the answer very short. 4.49. What is the difference between the highest and the second highest Balance of Payment (as % of service exports) in 2006?
Keep it short and to the point. 7.32. What is the difference between the highest and the second highest Balance of Payment (as % of service exports) of 2007?
Ensure brevity in your answer.  7.28. What is the difference between the highest and the second highest Balance of Payment (as % of service exports) of 2008?
Your answer should be compact. 7.36. What is the difference between the highest and the lowest Balance of Payment (as % of service exports) in 2005?
Keep it short and to the point. 6.56. What is the difference between the highest and the lowest Balance of Payment (as % of service exports) in 2006?
Make the answer very short. 9.11. What is the difference between the highest and the lowest Balance of Payment (as % of service exports) in 2007?
Provide a succinct answer. 8.85. What is the difference between the highest and the lowest Balance of Payment (as % of service exports) of 2008?
Give a very brief answer. 9. 